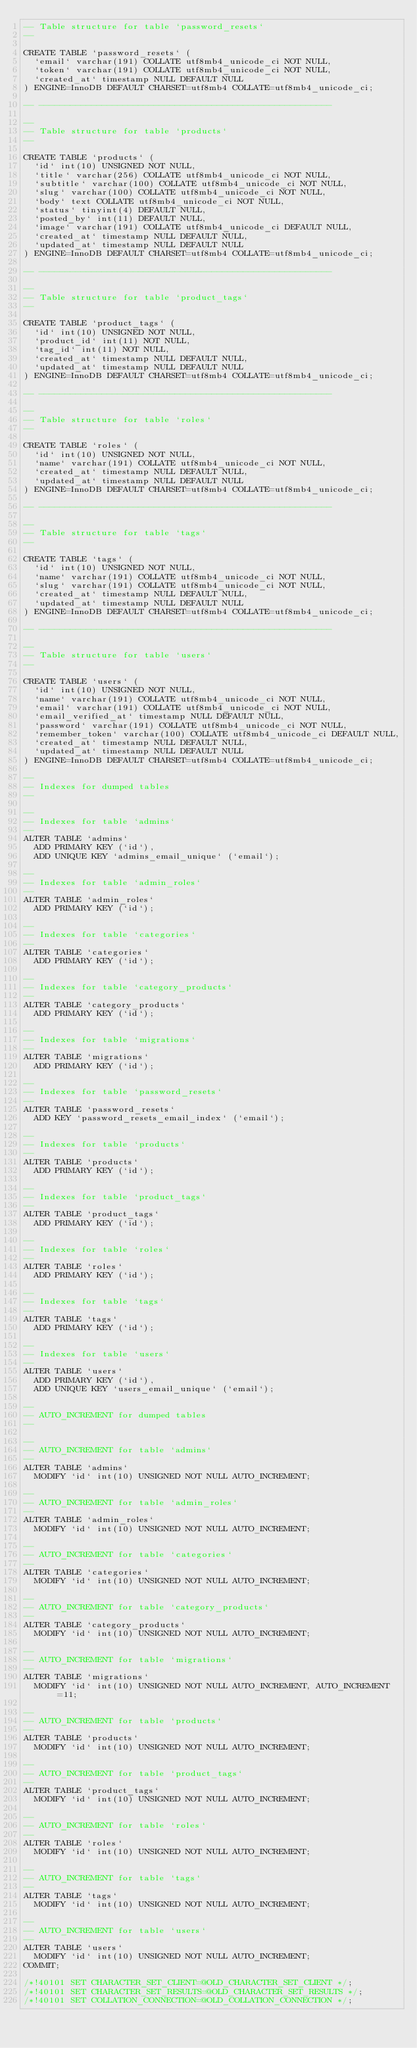<code> <loc_0><loc_0><loc_500><loc_500><_SQL_>-- Table structure for table `password_resets`
--

CREATE TABLE `password_resets` (
  `email` varchar(191) COLLATE utf8mb4_unicode_ci NOT NULL,
  `token` varchar(191) COLLATE utf8mb4_unicode_ci NOT NULL,
  `created_at` timestamp NULL DEFAULT NULL
) ENGINE=InnoDB DEFAULT CHARSET=utf8mb4 COLLATE=utf8mb4_unicode_ci;

-- --------------------------------------------------------

--
-- Table structure for table `products`
--

CREATE TABLE `products` (
  `id` int(10) UNSIGNED NOT NULL,
  `title` varchar(256) COLLATE utf8mb4_unicode_ci NOT NULL,
  `subtitle` varchar(100) COLLATE utf8mb4_unicode_ci NOT NULL,
  `slug` varchar(100) COLLATE utf8mb4_unicode_ci NOT NULL,
  `body` text COLLATE utf8mb4_unicode_ci NOT NULL,
  `status` tinyint(4) DEFAULT NULL,
  `posted_by` int(11) DEFAULT NULL,
  `image` varchar(191) COLLATE utf8mb4_unicode_ci DEFAULT NULL,
  `created_at` timestamp NULL DEFAULT NULL,
  `updated_at` timestamp NULL DEFAULT NULL
) ENGINE=InnoDB DEFAULT CHARSET=utf8mb4 COLLATE=utf8mb4_unicode_ci;

-- --------------------------------------------------------

--
-- Table structure for table `product_tags`
--

CREATE TABLE `product_tags` (
  `id` int(10) UNSIGNED NOT NULL,
  `product_id` int(11) NOT NULL,
  `tag_id` int(11) NOT NULL,
  `created_at` timestamp NULL DEFAULT NULL,
  `updated_at` timestamp NULL DEFAULT NULL
) ENGINE=InnoDB DEFAULT CHARSET=utf8mb4 COLLATE=utf8mb4_unicode_ci;

-- --------------------------------------------------------

--
-- Table structure for table `roles`
--

CREATE TABLE `roles` (
  `id` int(10) UNSIGNED NOT NULL,
  `name` varchar(191) COLLATE utf8mb4_unicode_ci NOT NULL,
  `created_at` timestamp NULL DEFAULT NULL,
  `updated_at` timestamp NULL DEFAULT NULL
) ENGINE=InnoDB DEFAULT CHARSET=utf8mb4 COLLATE=utf8mb4_unicode_ci;

-- --------------------------------------------------------

--
-- Table structure for table `tags`
--

CREATE TABLE `tags` (
  `id` int(10) UNSIGNED NOT NULL,
  `name` varchar(191) COLLATE utf8mb4_unicode_ci NOT NULL,
  `slug` varchar(191) COLLATE utf8mb4_unicode_ci NOT NULL,
  `created_at` timestamp NULL DEFAULT NULL,
  `updated_at` timestamp NULL DEFAULT NULL
) ENGINE=InnoDB DEFAULT CHARSET=utf8mb4 COLLATE=utf8mb4_unicode_ci;

-- --------------------------------------------------------

--
-- Table structure for table `users`
--

CREATE TABLE `users` (
  `id` int(10) UNSIGNED NOT NULL,
  `name` varchar(191) COLLATE utf8mb4_unicode_ci NOT NULL,
  `email` varchar(191) COLLATE utf8mb4_unicode_ci NOT NULL,
  `email_verified_at` timestamp NULL DEFAULT NULL,
  `password` varchar(191) COLLATE utf8mb4_unicode_ci NOT NULL,
  `remember_token` varchar(100) COLLATE utf8mb4_unicode_ci DEFAULT NULL,
  `created_at` timestamp NULL DEFAULT NULL,
  `updated_at` timestamp NULL DEFAULT NULL
) ENGINE=InnoDB DEFAULT CHARSET=utf8mb4 COLLATE=utf8mb4_unicode_ci;

--
-- Indexes for dumped tables
--

--
-- Indexes for table `admins`
--
ALTER TABLE `admins`
  ADD PRIMARY KEY (`id`),
  ADD UNIQUE KEY `admins_email_unique` (`email`);

--
-- Indexes for table `admin_roles`
--
ALTER TABLE `admin_roles`
  ADD PRIMARY KEY (`id`);

--
-- Indexes for table `categories`
--
ALTER TABLE `categories`
  ADD PRIMARY KEY (`id`);

--
-- Indexes for table `category_products`
--
ALTER TABLE `category_products`
  ADD PRIMARY KEY (`id`);

--
-- Indexes for table `migrations`
--
ALTER TABLE `migrations`
  ADD PRIMARY KEY (`id`);

--
-- Indexes for table `password_resets`
--
ALTER TABLE `password_resets`
  ADD KEY `password_resets_email_index` (`email`);

--
-- Indexes for table `products`
--
ALTER TABLE `products`
  ADD PRIMARY KEY (`id`);

--
-- Indexes for table `product_tags`
--
ALTER TABLE `product_tags`
  ADD PRIMARY KEY (`id`);

--
-- Indexes for table `roles`
--
ALTER TABLE `roles`
  ADD PRIMARY KEY (`id`);

--
-- Indexes for table `tags`
--
ALTER TABLE `tags`
  ADD PRIMARY KEY (`id`);

--
-- Indexes for table `users`
--
ALTER TABLE `users`
  ADD PRIMARY KEY (`id`),
  ADD UNIQUE KEY `users_email_unique` (`email`);

--
-- AUTO_INCREMENT for dumped tables
--

--
-- AUTO_INCREMENT for table `admins`
--
ALTER TABLE `admins`
  MODIFY `id` int(10) UNSIGNED NOT NULL AUTO_INCREMENT;

--
-- AUTO_INCREMENT for table `admin_roles`
--
ALTER TABLE `admin_roles`
  MODIFY `id` int(10) UNSIGNED NOT NULL AUTO_INCREMENT;

--
-- AUTO_INCREMENT for table `categories`
--
ALTER TABLE `categories`
  MODIFY `id` int(10) UNSIGNED NOT NULL AUTO_INCREMENT;

--
-- AUTO_INCREMENT for table `category_products`
--
ALTER TABLE `category_products`
  MODIFY `id` int(10) UNSIGNED NOT NULL AUTO_INCREMENT;

--
-- AUTO_INCREMENT for table `migrations`
--
ALTER TABLE `migrations`
  MODIFY `id` int(10) UNSIGNED NOT NULL AUTO_INCREMENT, AUTO_INCREMENT=11;

--
-- AUTO_INCREMENT for table `products`
--
ALTER TABLE `products`
  MODIFY `id` int(10) UNSIGNED NOT NULL AUTO_INCREMENT;

--
-- AUTO_INCREMENT for table `product_tags`
--
ALTER TABLE `product_tags`
  MODIFY `id` int(10) UNSIGNED NOT NULL AUTO_INCREMENT;

--
-- AUTO_INCREMENT for table `roles`
--
ALTER TABLE `roles`
  MODIFY `id` int(10) UNSIGNED NOT NULL AUTO_INCREMENT;

--
-- AUTO_INCREMENT for table `tags`
--
ALTER TABLE `tags`
  MODIFY `id` int(10) UNSIGNED NOT NULL AUTO_INCREMENT;

--
-- AUTO_INCREMENT for table `users`
--
ALTER TABLE `users`
  MODIFY `id` int(10) UNSIGNED NOT NULL AUTO_INCREMENT;
COMMIT;

/*!40101 SET CHARACTER_SET_CLIENT=@OLD_CHARACTER_SET_CLIENT */;
/*!40101 SET CHARACTER_SET_RESULTS=@OLD_CHARACTER_SET_RESULTS */;
/*!40101 SET COLLATION_CONNECTION=@OLD_COLLATION_CONNECTION */;
</code> 